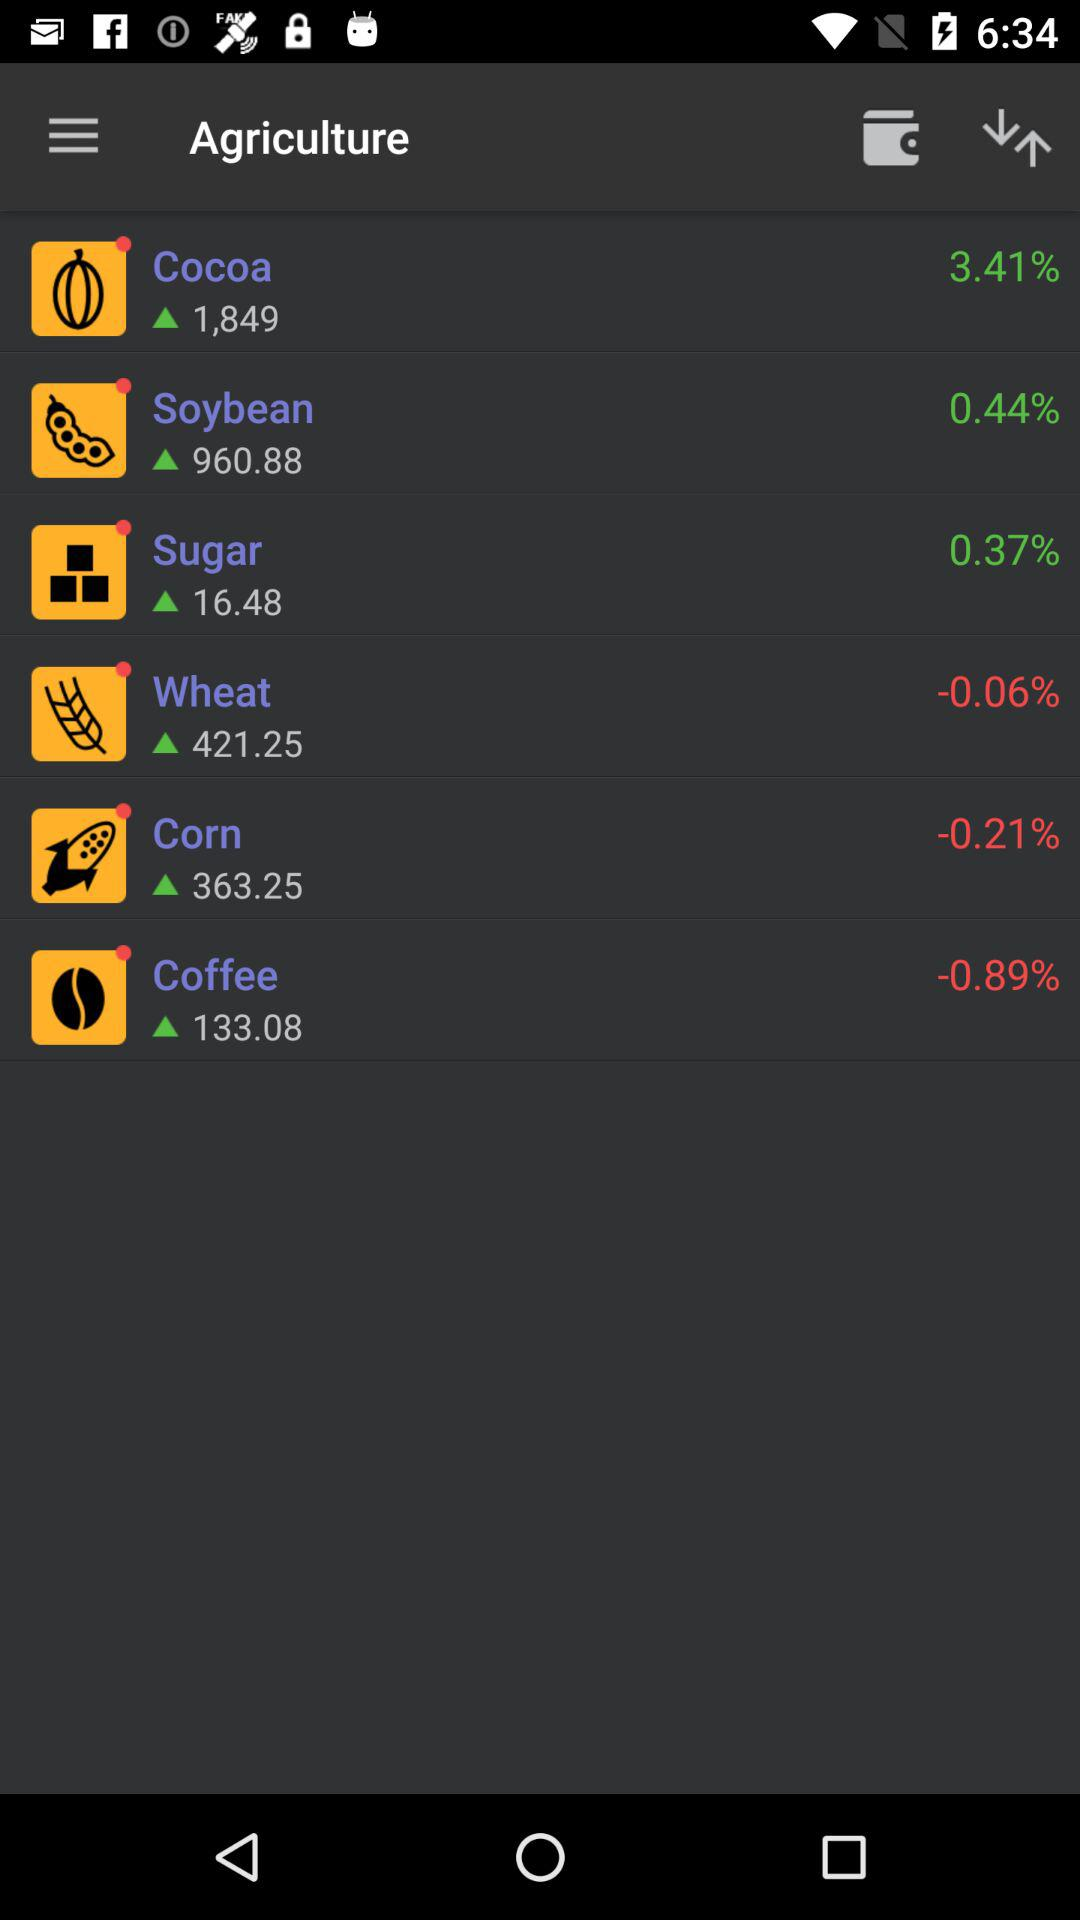Which commodity has the highest percentage increase?
Answer the question using a single word or phrase. Cocoa 